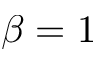<formula> <loc_0><loc_0><loc_500><loc_500>\beta = 1</formula> 